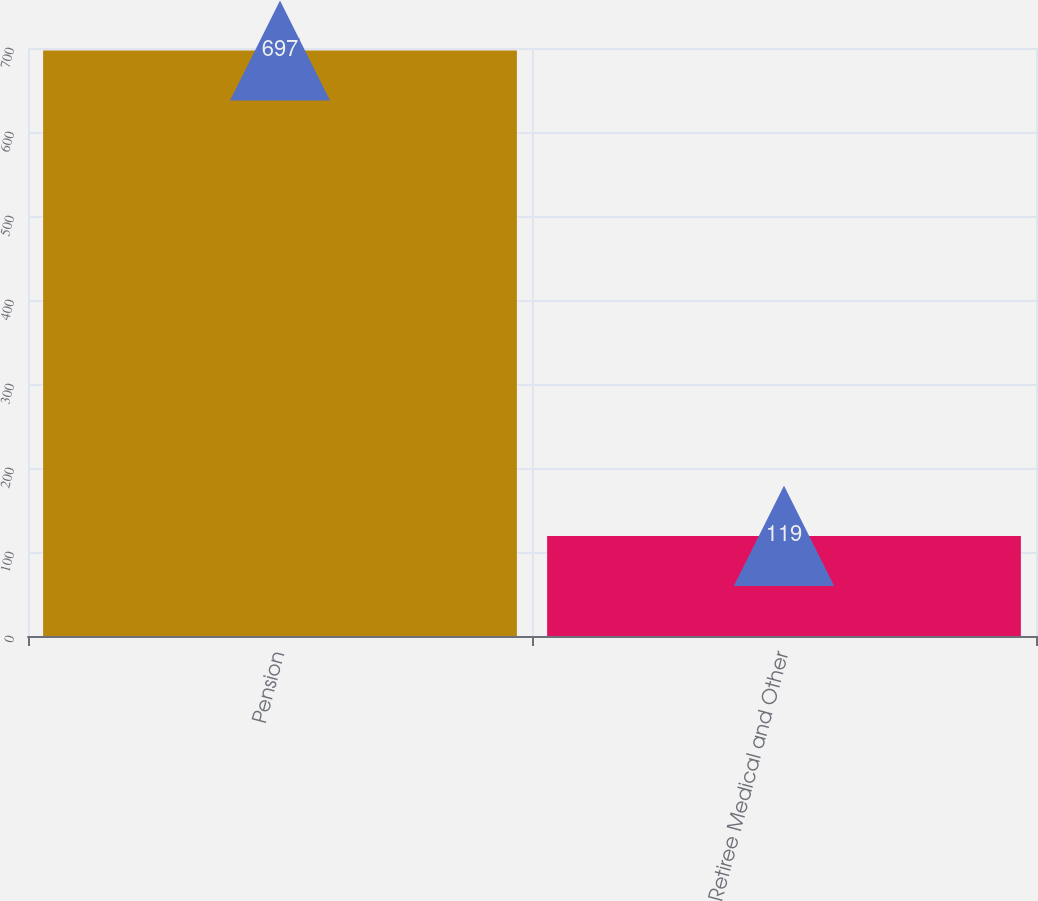Convert chart to OTSL. <chart><loc_0><loc_0><loc_500><loc_500><bar_chart><fcel>Pension<fcel>Retiree Medical and Other<nl><fcel>697<fcel>119<nl></chart> 